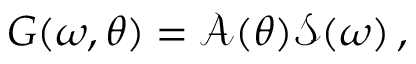Convert formula to latex. <formula><loc_0><loc_0><loc_500><loc_500>G ( \omega , \theta ) = \mathcal { A } ( \theta ) \mathcal { S } ( \omega ) \, ,</formula> 